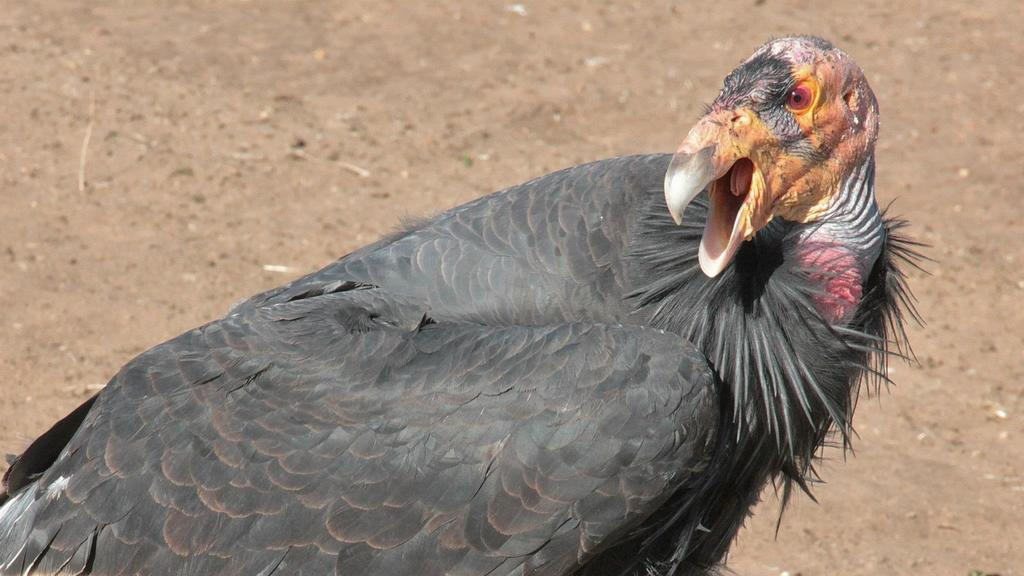What type of animal is present in the image? There is a bird in the image. What type of popcorn is the judge eating while the porter watches in the image? There is no porter, judge, or popcorn present in the image; it only features a bird. 